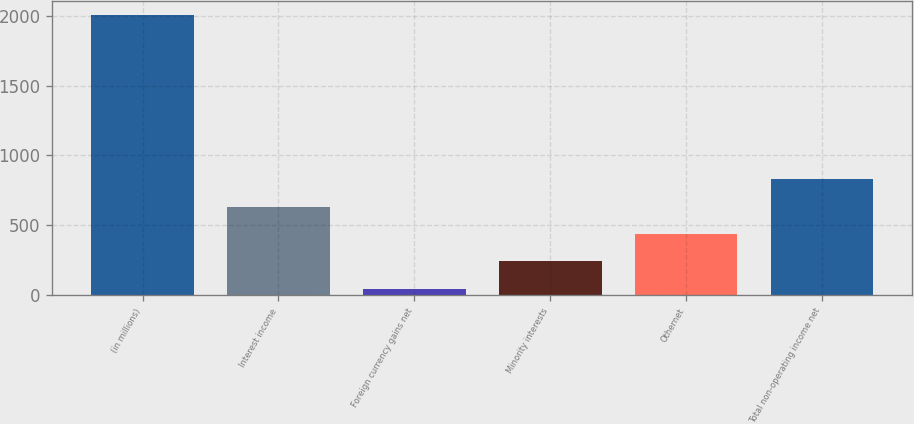<chart> <loc_0><loc_0><loc_500><loc_500><bar_chart><fcel>(in millions)<fcel>Interest income<fcel>Foreign currency gains net<fcel>Minority interests<fcel>Othernet<fcel>Total non-operating income net<nl><fcel>2007<fcel>633.6<fcel>45<fcel>241.2<fcel>437.4<fcel>829.8<nl></chart> 